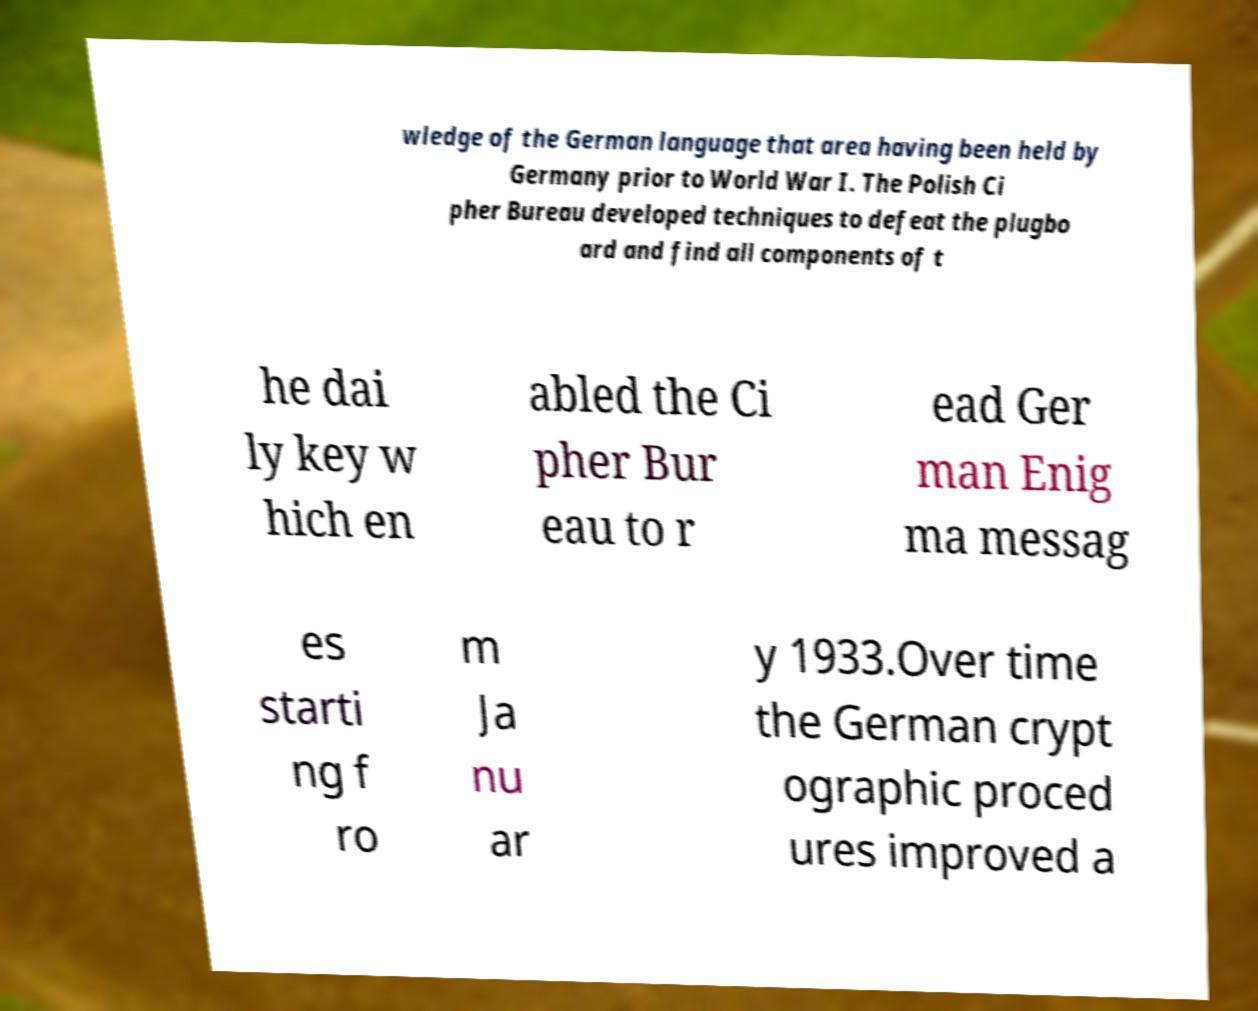There's text embedded in this image that I need extracted. Can you transcribe it verbatim? wledge of the German language that area having been held by Germany prior to World War I. The Polish Ci pher Bureau developed techniques to defeat the plugbo ard and find all components of t he dai ly key w hich en abled the Ci pher Bur eau to r ead Ger man Enig ma messag es starti ng f ro m Ja nu ar y 1933.Over time the German crypt ographic proced ures improved a 